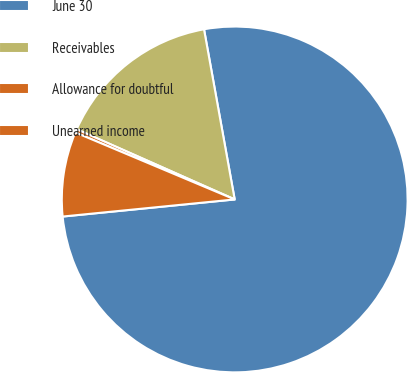Convert chart. <chart><loc_0><loc_0><loc_500><loc_500><pie_chart><fcel>June 30<fcel>Receivables<fcel>Allowance for doubtful<fcel>Unearned income<nl><fcel>76.27%<fcel>15.51%<fcel>0.32%<fcel>7.91%<nl></chart> 